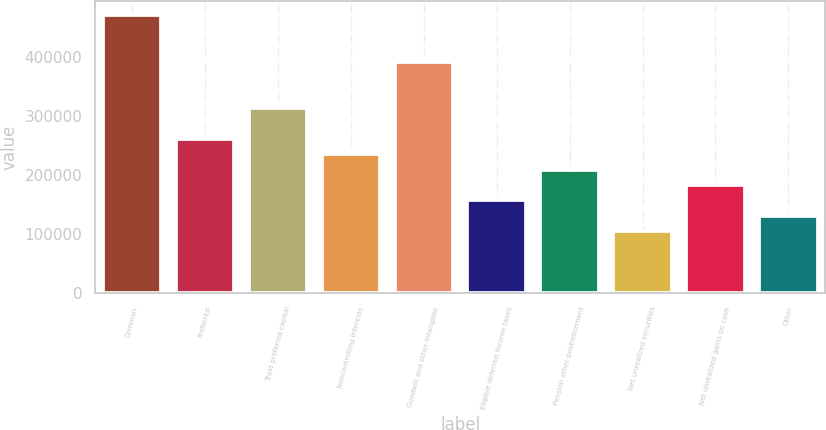Convert chart to OTSL. <chart><loc_0><loc_0><loc_500><loc_500><bar_chart><fcel>Common<fcel>Preferred<fcel>Trust preferred capital<fcel>Noncontrolling interests<fcel>Goodwill and other intangible<fcel>Eligible deferred income taxes<fcel>Pension other postretirement<fcel>Net unrealized securities<fcel>Net unrealized gains on cash<fcel>Other<nl><fcel>471516<fcel>261958<fcel>314348<fcel>235763<fcel>392932<fcel>157179<fcel>209568<fcel>104789<fcel>183374<fcel>130984<nl></chart> 